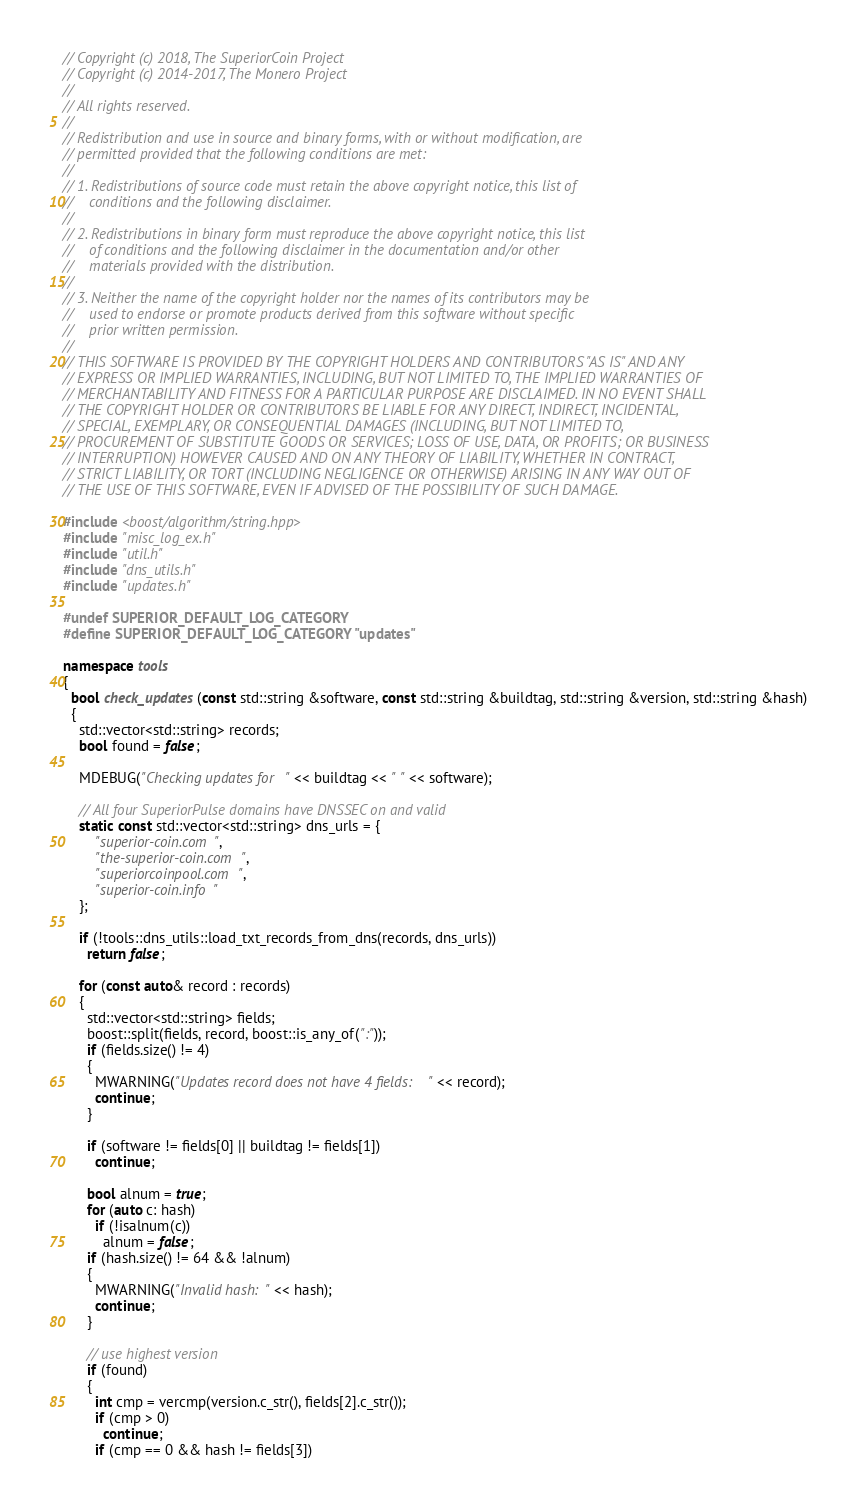Convert code to text. <code><loc_0><loc_0><loc_500><loc_500><_C++_>// Copyright (c) 2018, The SuperiorCoin Project
// Copyright (c) 2014-2017, The Monero Project
// 
// All rights reserved.
// 
// Redistribution and use in source and binary forms, with or without modification, are
// permitted provided that the following conditions are met:
// 
// 1. Redistributions of source code must retain the above copyright notice, this list of
//    conditions and the following disclaimer.
// 
// 2. Redistributions in binary form must reproduce the above copyright notice, this list
//    of conditions and the following disclaimer in the documentation and/or other
//    materials provided with the distribution.
// 
// 3. Neither the name of the copyright holder nor the names of its contributors may be
//    used to endorse or promote products derived from this software without specific
//    prior written permission.
// 
// THIS SOFTWARE IS PROVIDED BY THE COPYRIGHT HOLDERS AND CONTRIBUTORS "AS IS" AND ANY
// EXPRESS OR IMPLIED WARRANTIES, INCLUDING, BUT NOT LIMITED TO, THE IMPLIED WARRANTIES OF
// MERCHANTABILITY AND FITNESS FOR A PARTICULAR PURPOSE ARE DISCLAIMED. IN NO EVENT SHALL
// THE COPYRIGHT HOLDER OR CONTRIBUTORS BE LIABLE FOR ANY DIRECT, INDIRECT, INCIDENTAL,
// SPECIAL, EXEMPLARY, OR CONSEQUENTIAL DAMAGES (INCLUDING, BUT NOT LIMITED TO,
// PROCUREMENT OF SUBSTITUTE GOODS OR SERVICES; LOSS OF USE, DATA, OR PROFITS; OR BUSINESS
// INTERRUPTION) HOWEVER CAUSED AND ON ANY THEORY OF LIABILITY, WHETHER IN CONTRACT,
// STRICT LIABILITY, OR TORT (INCLUDING NEGLIGENCE OR OTHERWISE) ARISING IN ANY WAY OUT OF
// THE USE OF THIS SOFTWARE, EVEN IF ADVISED OF THE POSSIBILITY OF SUCH DAMAGE.

#include <boost/algorithm/string.hpp>
#include "misc_log_ex.h"
#include "util.h"
#include "dns_utils.h"
#include "updates.h"

#undef SUPERIOR_DEFAULT_LOG_CATEGORY
#define SUPERIOR_DEFAULT_LOG_CATEGORY "updates"

namespace tools
{
  bool check_updates(const std::string &software, const std::string &buildtag, std::string &version, std::string &hash)
  {
    std::vector<std::string> records;
    bool found = false;

    MDEBUG("Checking updates for " << buildtag << " " << software);

    // All four SuperiorPulse domains have DNSSEC on and valid
    static const std::vector<std::string> dns_urls = {
        "superior-coin.com",
        "the-superior-coin.com",
        "superiorcoinpool.com",
        "superior-coin.info"
    };

    if (!tools::dns_utils::load_txt_records_from_dns(records, dns_urls))
      return false;

    for (const auto& record : records)
    {
      std::vector<std::string> fields;
      boost::split(fields, record, boost::is_any_of(":"));
      if (fields.size() != 4)
      {
        MWARNING("Updates record does not have 4 fields: " << record);
        continue;
      }

      if (software != fields[0] || buildtag != fields[1])
        continue;

      bool alnum = true;
      for (auto c: hash)
        if (!isalnum(c))
          alnum = false;
      if (hash.size() != 64 && !alnum)
      {
        MWARNING("Invalid hash: " << hash);
        continue;
      }

      // use highest version
      if (found)
      {
        int cmp = vercmp(version.c_str(), fields[2].c_str());
        if (cmp > 0)
          continue;
        if (cmp == 0 && hash != fields[3])</code> 